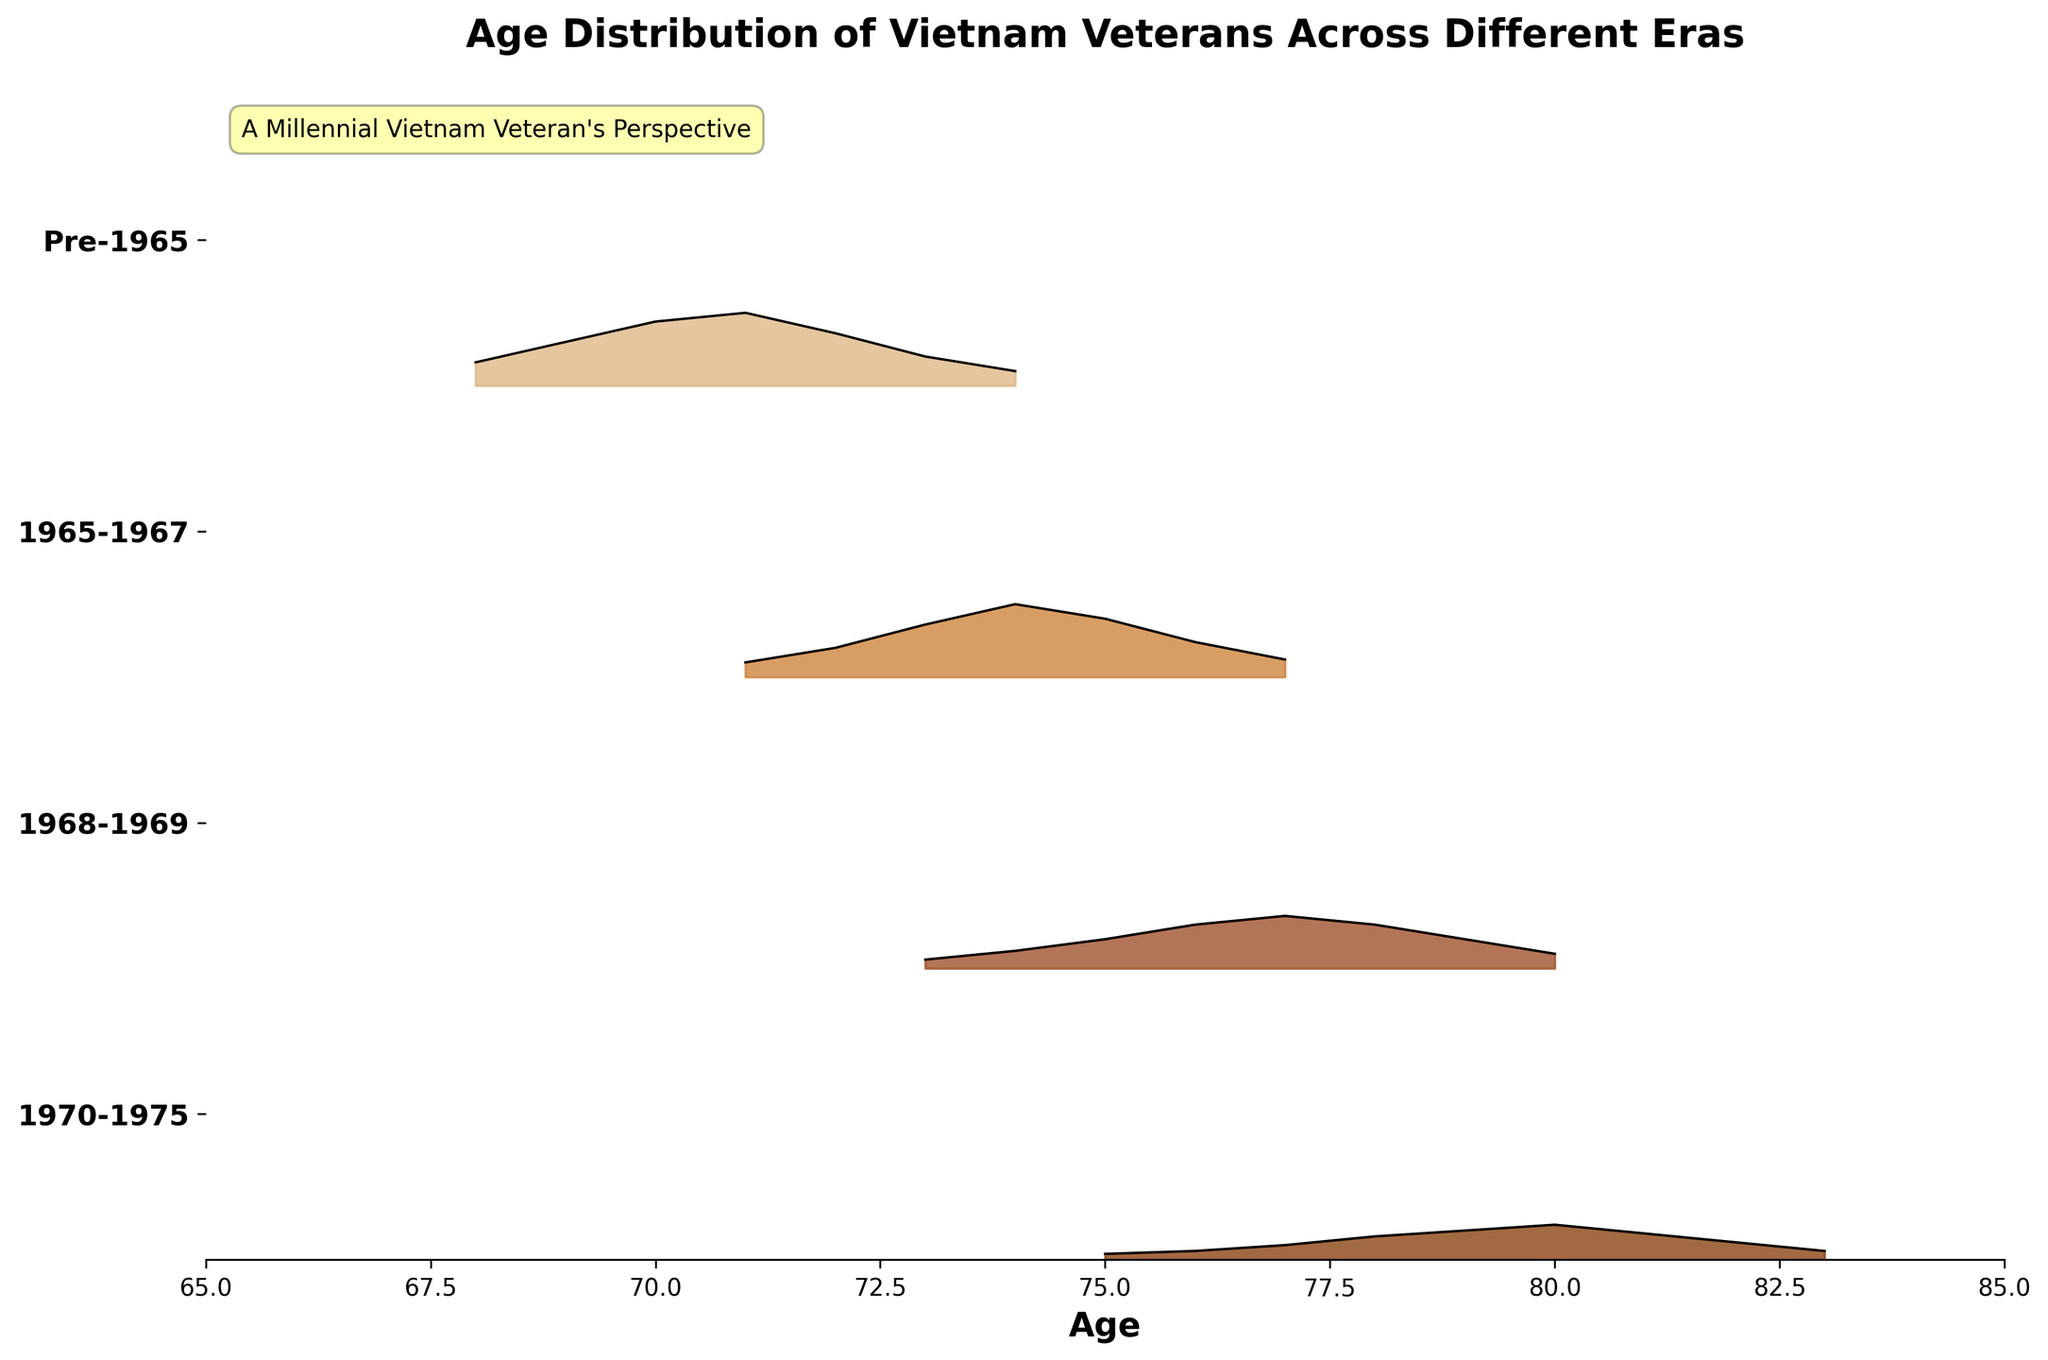How many eras are represented in the figure? There are four unique eras represented in the figure, which can be seen by the four distinct ridgelines portrayed.
Answer: 4 What is the title of the figure? The title is located at the top of the figure and it reads "Age Distribution of Vietnam Veterans Across Different Eras".
Answer: Age Distribution of Vietnam Veterans Across Different Eras Which era has the highest peak density? The ridgeline for the era "1968-1969" has the highest peak density. This can be observed where the curve reaches its highest point relative to the y-axis.
Answer: 1968-1969 Which era has the oldest veterans according to the plot? The oldest age on the x-axis corresponds to the "Pre-1965" era, seen on the leftmost ridgeline.
Answer: Pre-1965 What's the average age of the highest density point in the "1970-1975" era? The highest density in the "1970-1975" era occurs around age 71, where the curve is at its peak. Since there are no other peaks, the average is 71.
Answer: 71 Compare the densities of ages 75 in the "Pre-1965" and "1968-1969" eras. Which is higher? By observing both ridgelines at age 75, "1968-1969" has a higher density as its curve is positioned higher relative to the density axis compared to "Pre-1965".
Answer: 1968-1969 In which era is there a steep drop in density after the peak age? In the "1968-1969" era, there is a notable steep drop in density following the peak at age 74.
Answer: 1968-1969 What's the common age range for veterans across all eras? The common age range across all eras can be determined by finding the overlap on the x-axis, which is 71 to 79 years.
Answer: 71 to 79 years Which era shows veterans peaking at age 77? The "1965-1967" era shows a peak in density at age 77, indicated by the highest point in its ridgeline.
Answer: 1965-1967 How does the density distribution of "Pre-1965" compare to "1970-1975"? "Pre-1965" has a wider and more uniform distribution compared to "1970-1975", which shows a sharp peak and a quick drop-off after.
Answer: "Pre-1965" is wider and more uniform 